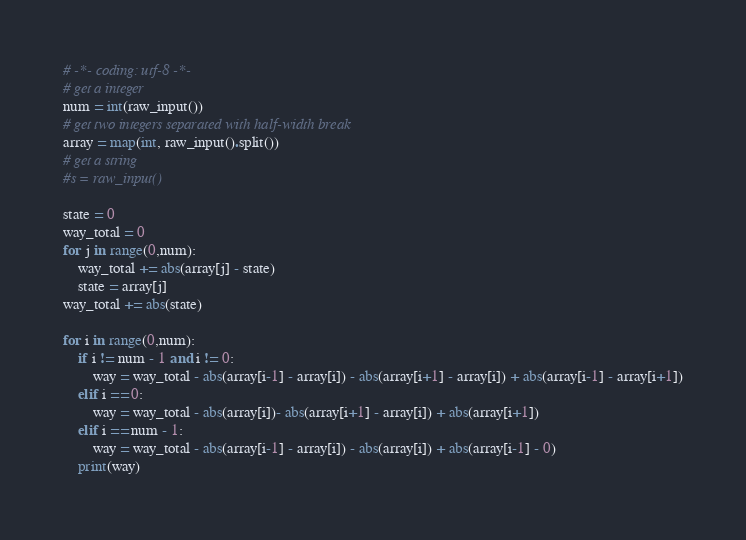Convert code to text. <code><loc_0><loc_0><loc_500><loc_500><_Python_># -*- coding: utf-8 -*-
# get a integer
num = int(raw_input())
# get two integers separated with half-width break
array = map(int, raw_input().split())
# get a string
#s = raw_input()

state = 0
way_total = 0
for j in range(0,num):
    way_total += abs(array[j] - state)
    state = array[j]
way_total += abs(state)

for i in range(0,num):
    if i != num - 1 and i != 0:
        way = way_total - abs(array[i-1] - array[i]) - abs(array[i+1] - array[i]) + abs(array[i-1] - array[i+1])
    elif i == 0:
        way = way_total - abs(array[i])- abs(array[i+1] - array[i]) + abs(array[i+1])
    elif i == num - 1:
        way = way_total - abs(array[i-1] - array[i]) - abs(array[i]) + abs(array[i-1] - 0)
    print(way)
</code> 